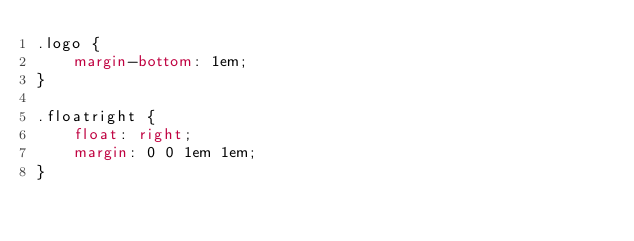Convert code to text. <code><loc_0><loc_0><loc_500><loc_500><_CSS_>.logo {
    margin-bottom: 1em;
}

.floatright {
    float: right;
    margin: 0 0 1em 1em;
}
</code> 